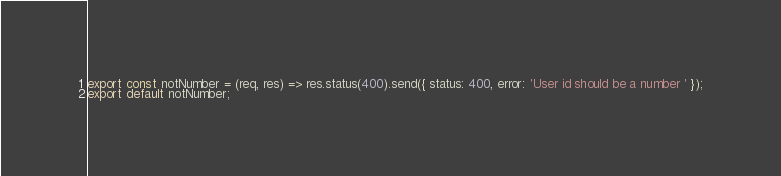Convert code to text. <code><loc_0><loc_0><loc_500><loc_500><_JavaScript_>
export const notNumber = (req, res) => res.status(400).send({ status: 400, error: 'User id should be a number ' });
export default notNumber;
</code> 